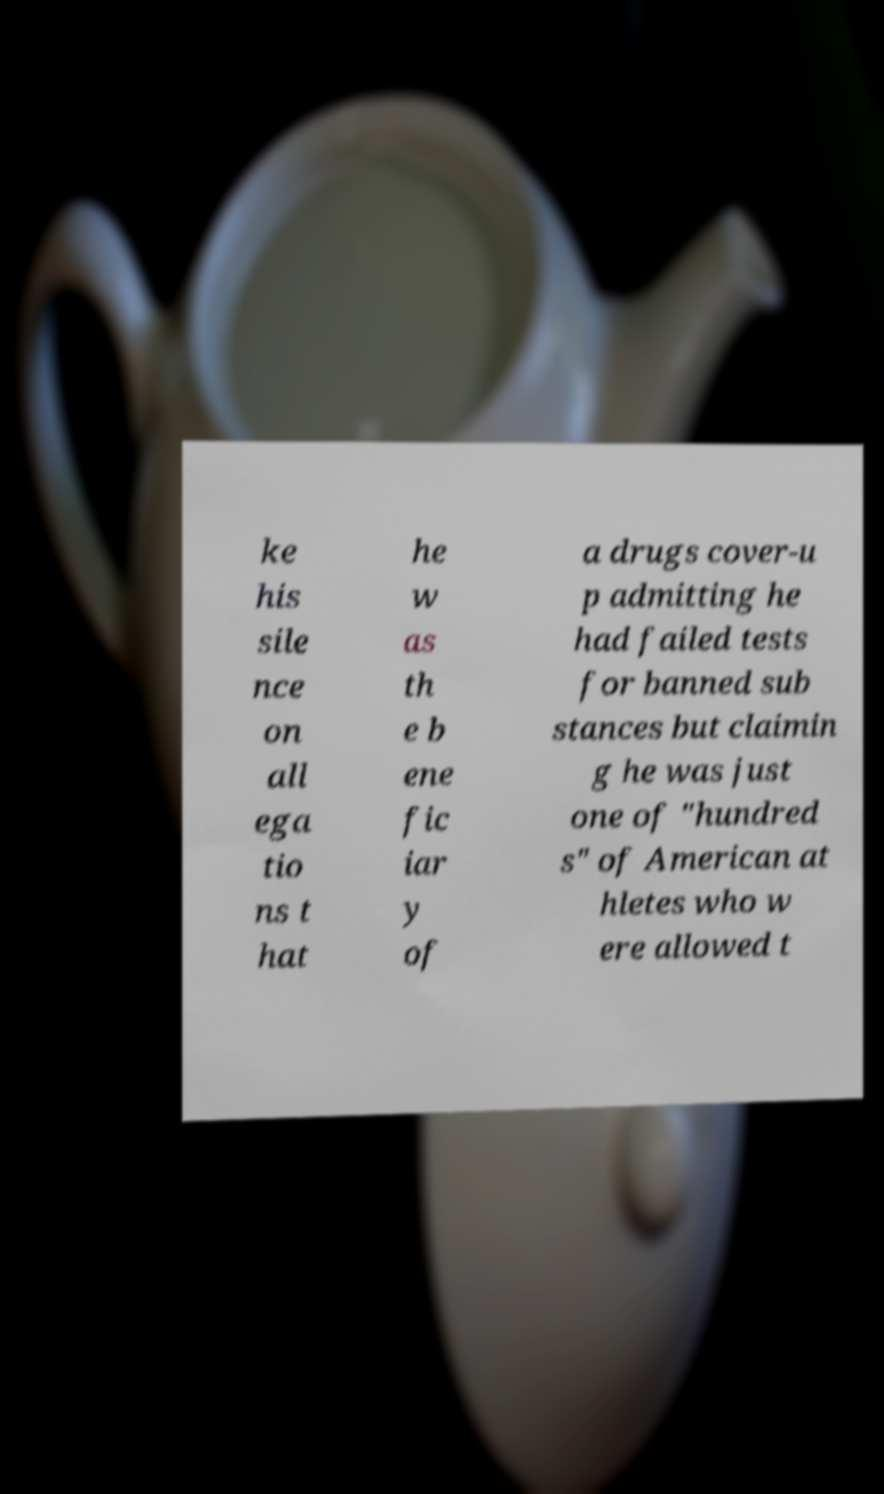Can you accurately transcribe the text from the provided image for me? ke his sile nce on all ega tio ns t hat he w as th e b ene fic iar y of a drugs cover-u p admitting he had failed tests for banned sub stances but claimin g he was just one of "hundred s" of American at hletes who w ere allowed t 